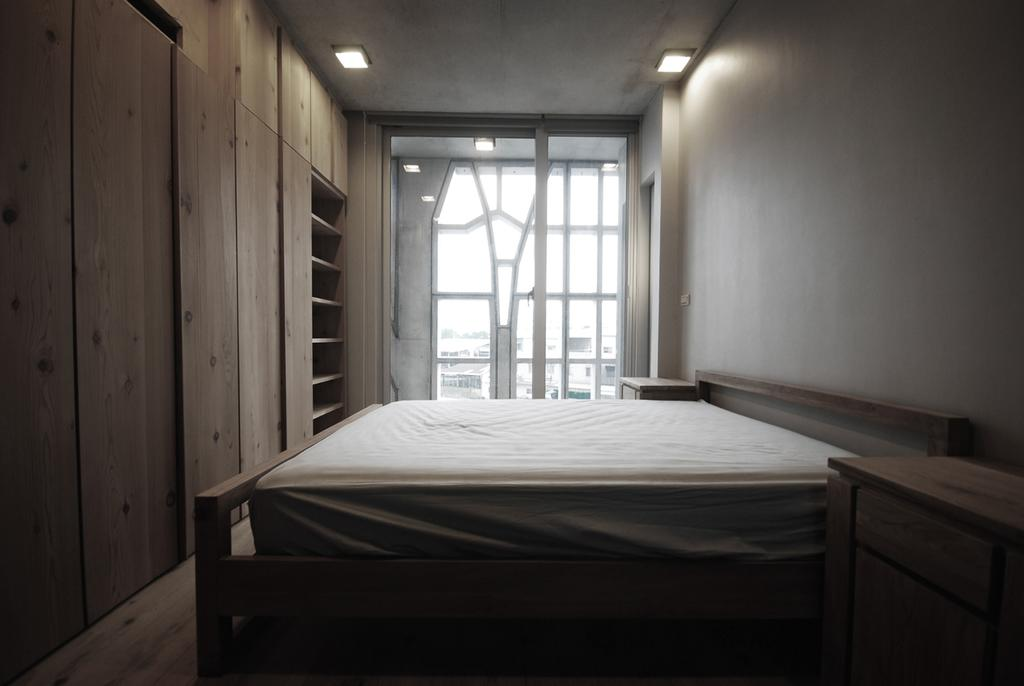What type of furniture is in the image? There is a cot in the image. What is on top of the cot? There is a bed on the cot. What type of storage furniture is on the left side of the image? There are wooden cabinets on the left side of the image. What can be seen in the background of the image? There is a window in the background of the image. Is there a volcano erupting in the background of the image? No, there is no volcano present in the image. The background features a window, not a volcanic eruption. 